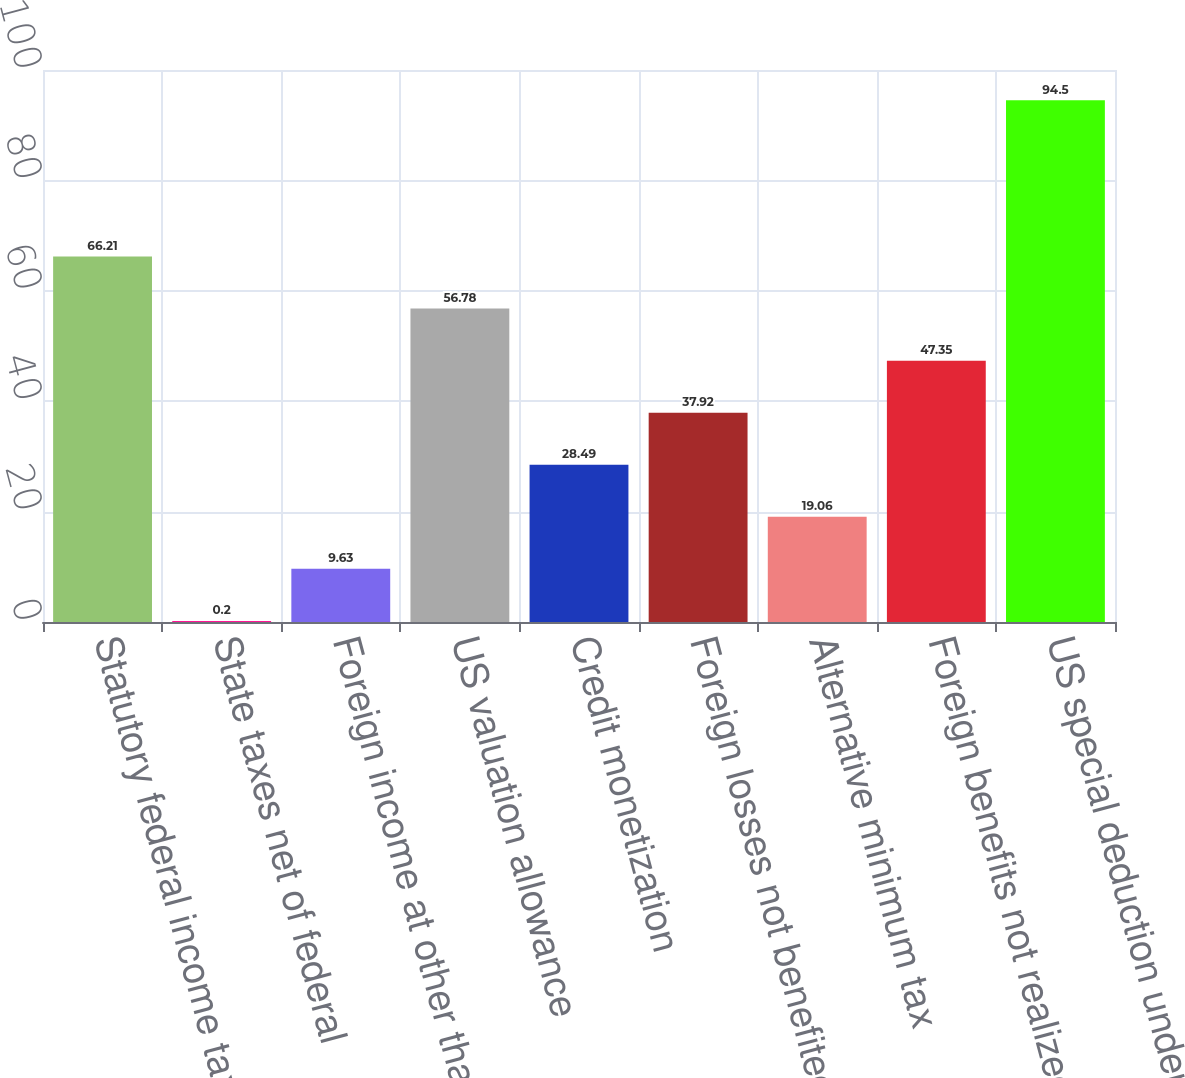Convert chart. <chart><loc_0><loc_0><loc_500><loc_500><bar_chart><fcel>Statutory federal income tax<fcel>State taxes net of federal<fcel>Foreign income at other than<fcel>US valuation allowance<fcel>Credit monetization<fcel>Foreign losses not benefited<fcel>Alternative minimum tax<fcel>Foreign benefits not realized<fcel>US special deduction under IRC<nl><fcel>66.21<fcel>0.2<fcel>9.63<fcel>56.78<fcel>28.49<fcel>37.92<fcel>19.06<fcel>47.35<fcel>94.5<nl></chart> 